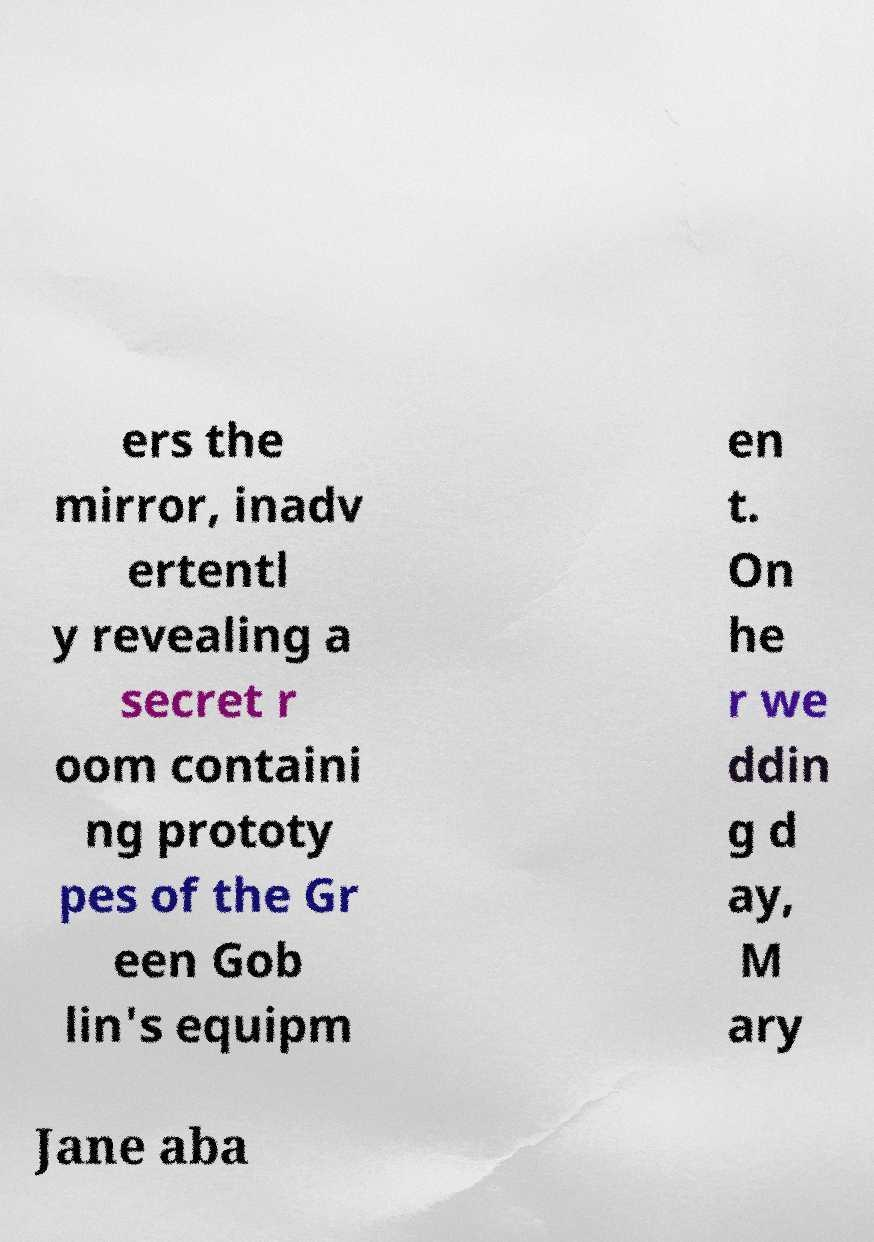Could you extract and type out the text from this image? ers the mirror, inadv ertentl y revealing a secret r oom containi ng prototy pes of the Gr een Gob lin's equipm en t. On he r we ddin g d ay, M ary Jane aba 